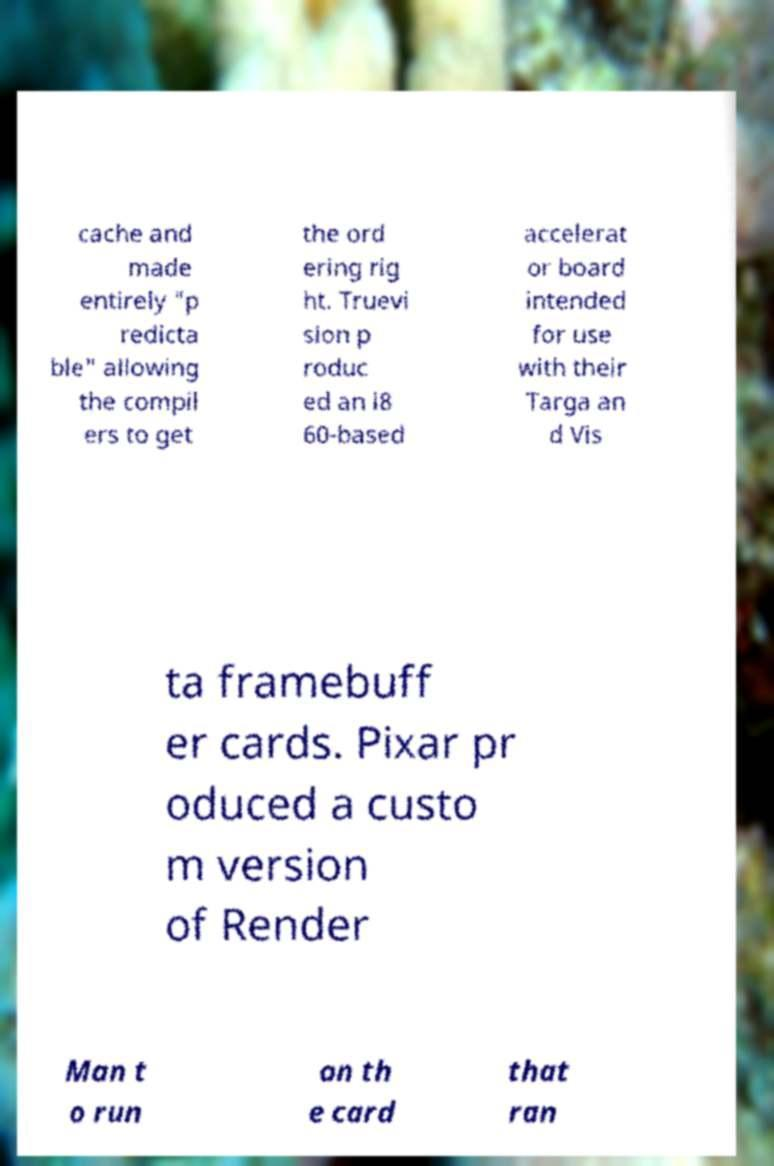Can you read and provide the text displayed in the image?This photo seems to have some interesting text. Can you extract and type it out for me? cache and made entirely "p redicta ble" allowing the compil ers to get the ord ering rig ht. Truevi sion p roduc ed an i8 60-based accelerat or board intended for use with their Targa an d Vis ta framebuff er cards. Pixar pr oduced a custo m version of Render Man t o run on th e card that ran 